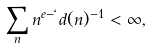Convert formula to latex. <formula><loc_0><loc_0><loc_500><loc_500>\sum _ { n } n ^ { e - \ell } d ( n ) ^ { - 1 } < \infty ,</formula> 